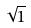Convert formula to latex. <formula><loc_0><loc_0><loc_500><loc_500>\sqrt { 1 }</formula> 